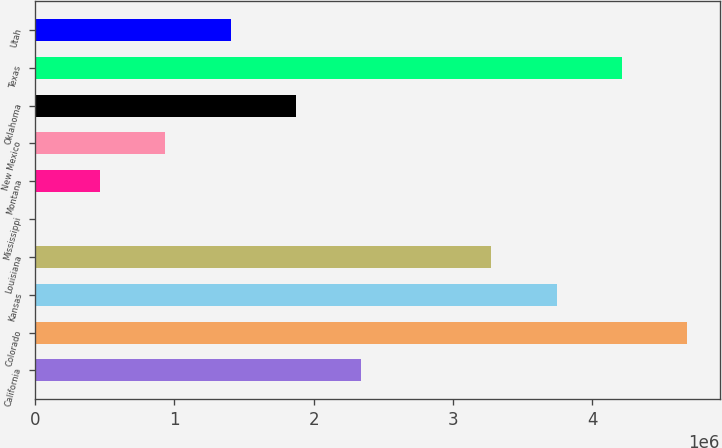Convert chart. <chart><loc_0><loc_0><loc_500><loc_500><bar_chart><fcel>California<fcel>Colorado<fcel>Kansas<fcel>Louisiana<fcel>Mississippi<fcel>Montana<fcel>New Mexico<fcel>Oklahoma<fcel>Texas<fcel>Utah<nl><fcel>2.34045e+06<fcel>4.68086e+06<fcel>3.7447e+06<fcel>3.27662e+06<fcel>51<fcel>468132<fcel>936212<fcel>1.87237e+06<fcel>4.21278e+06<fcel>1.40429e+06<nl></chart> 